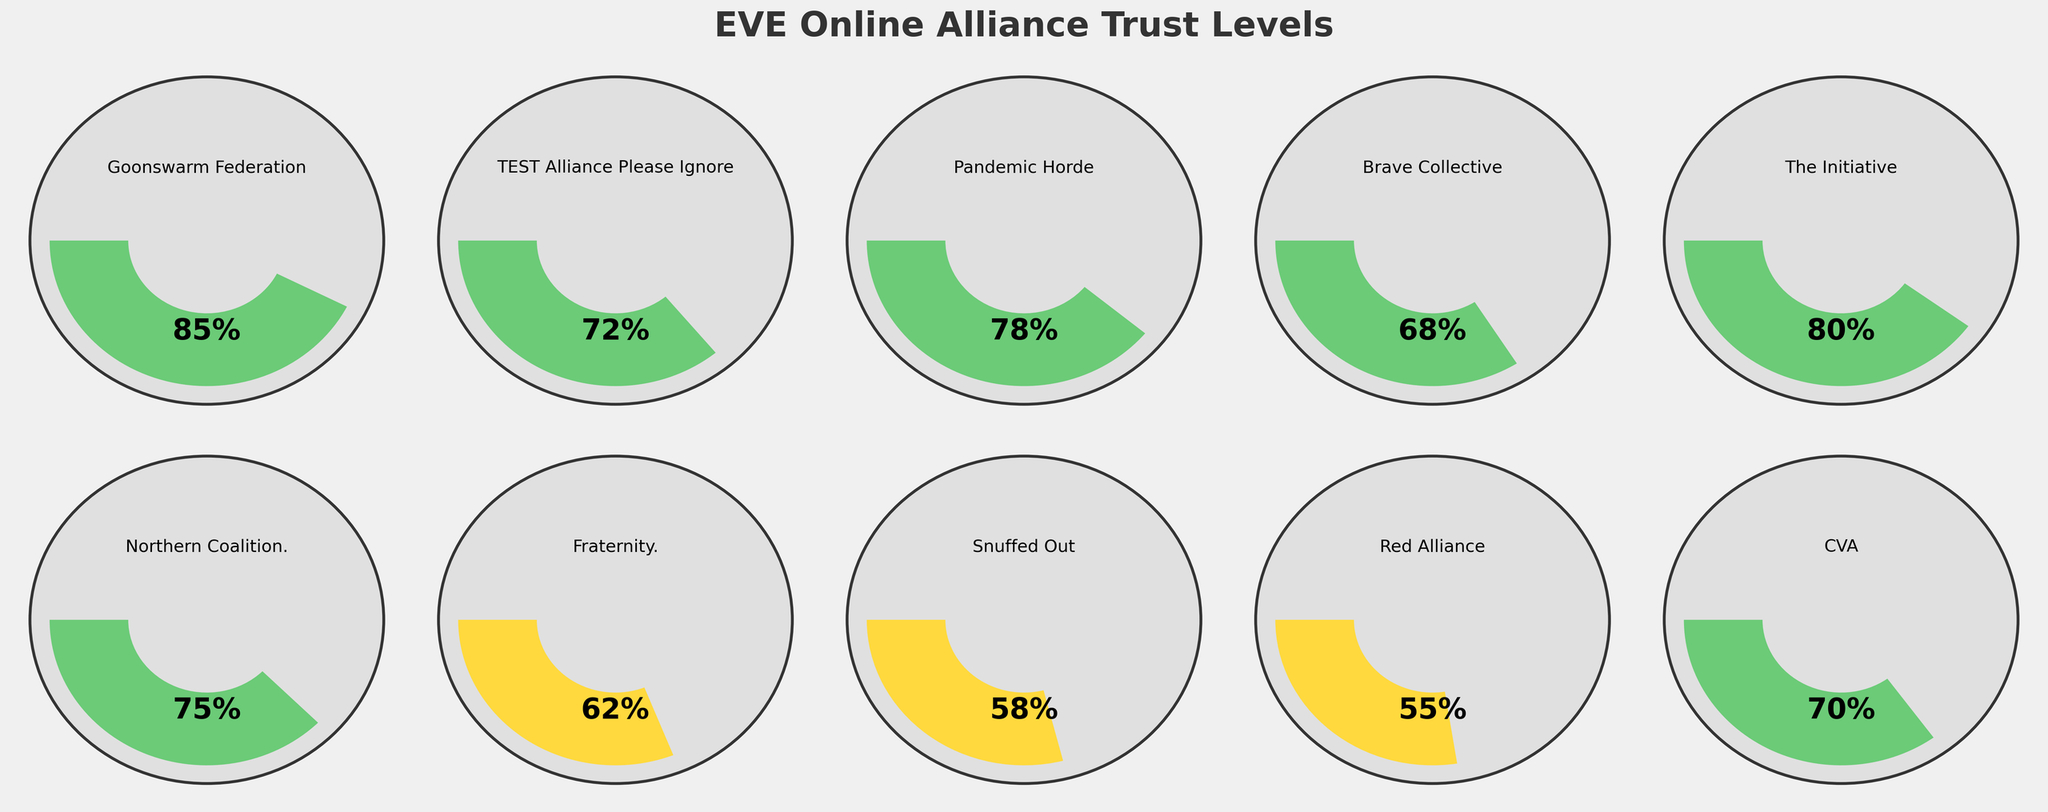Which alliance has the highest trust level? By inspecting the figure, the Goonswarm Federation has the highest trust level gauge indicating 85%.
Answer: Goonswarm Federation What is the title of the figure? The title of the figure is prominently displayed at the top and reads "EVE Online Alliance Trust Levels."
Answer: EVE Online Alliance Trust Levels Which alliance has a trust level of 55%? Looking at the figure, the gauge for Red Alliance is set at 55%.
Answer: Red Alliance What is the difference in trust level between Brave Collective and Fraternity.? Observing the figure, Brave Collective has a trust level of 68%, and Fraternity. has a trust level of 62%. The difference is 68% - 62%.
Answer: 6% What color is most associated with the highest trust levels on the gauges? By examining the gauges, the highest trust levels are indicated by a dark green color.
Answer: Green Which alliance has a lower trust level between TEST Alliance Please Ignore and Northern Coalition.? Comparing the two gauges, TEST Alliance Please Ignore has 72% and Northern Coalition. has 75%. Thus, TEST Alliance Please Ignore has a lower trust level.
Answer: TEST Alliance Please Ignore How many alliances have a trust level above 70%? By counting the gauges with trust levels above 70%, we find there are five: Goonswarm Federation, TEST Alliance Please Ignore, Pandemic Horde, The Initiative, and Northern Coalition.
Answer: 5 What's the average trust level of all listed alliances? To find the average, sum all the trust levels and divide by the number of alliances. (85 + 72 + 78 + 68 + 80 + 75 + 62 + 58 + 55 + 70) / 10 = 70.3%
Answer: 70.3% What color is associated with a trust level of 58%? By observing the gauge colors, the trust level of 58%, which belongs to Snuffed Out, is in yellow.
Answer: Yellow 